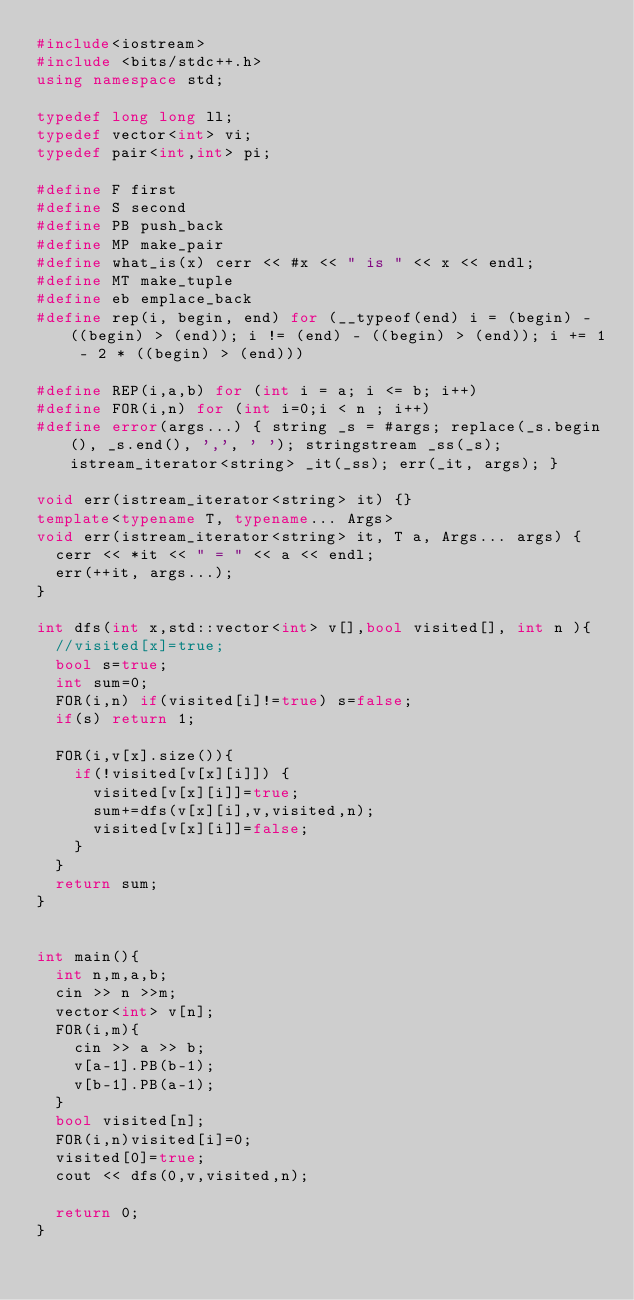<code> <loc_0><loc_0><loc_500><loc_500><_C++_>#include<iostream>
#include <bits/stdc++.h>
using namespace std;

typedef long long ll;
typedef vector<int> vi;
typedef pair<int,int> pi;

#define F first
#define S second
#define PB push_back
#define MP make_pair
#define what_is(x) cerr << #x << " is " << x << endl;
#define MT make_tuple
#define eb emplace_back
#define rep(i, begin, end) for (__typeof(end) i = (begin) - ((begin) > (end)); i != (end) - ((begin) > (end)); i += 1 - 2 * ((begin) > (end)))

#define REP(i,a,b) for (int i = a; i <= b; i++)
#define FOR(i,n) for (int i=0;i < n ; i++)
#define error(args...) { string _s = #args; replace(_s.begin(), _s.end(), ',', ' '); stringstream _ss(_s); istream_iterator<string> _it(_ss); err(_it, args); }

void err(istream_iterator<string> it) {}
template<typename T, typename... Args>
void err(istream_iterator<string> it, T a, Args... args) {
	cerr << *it << " = " << a << endl;
	err(++it, args...);
}

int dfs(int x,std::vector<int> v[],bool visited[], int n ){
	//visited[x]=true;
	bool s=true;
	int sum=0;
	FOR(i,n) if(visited[i]!=true) s=false;
	if(s) return 1;
	
	FOR(i,v[x].size()){
		if(!visited[v[x][i]]) {
			visited[v[x][i]]=true;
			sum+=dfs(v[x][i],v,visited,n); 
			visited[v[x][i]]=false;
		}
	}
	return sum;
}


int main(){
	int n,m,a,b;
	cin >> n >>m;
	vector<int> v[n];
	FOR(i,m){
		cin >> a >> b;
		v[a-1].PB(b-1);
		v[b-1].PB(a-1);
	}
	bool visited[n];
	FOR(i,n)visited[i]=0;
	visited[0]=true;
	cout << dfs(0,v,visited,n);

	return 0;
}</code> 